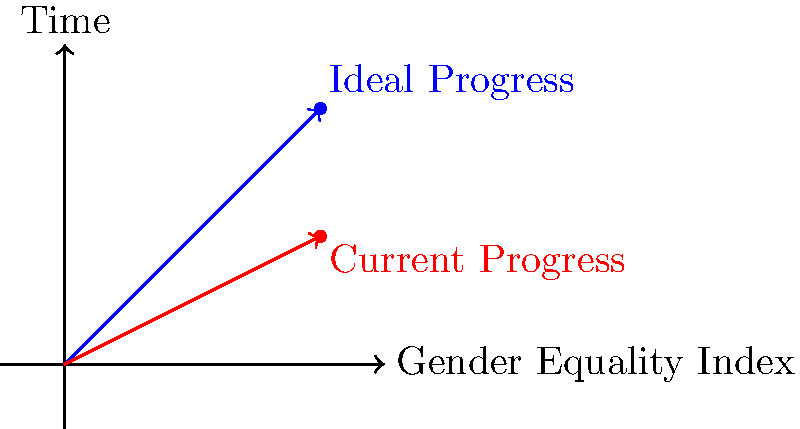In the vector diagram representing gender equality progress over time, the blue arrow shows the ideal progress, while the red arrow shows the current progress. If the magnitude of the ideal progress vector is 4√2 units, what is the magnitude of the current progress vector? To solve this problem, let's follow these steps:

1. Identify the vectors:
   - Blue vector (ideal progress): from (0,0) to (4,4)
   - Red vector (current progress): from (0,0) to (4,2)

2. Calculate the magnitude of the ideal progress vector:
   - Given as 4√2 units

3. Find the components of the current progress vector:
   - x-component: 4 units
   - y-component: 2 units

4. Use the Pythagorean theorem to calculate the magnitude of the current progress vector:
   $$\text{magnitude} = \sqrt{x^2 + y^2}$$
   $$\text{magnitude} = \sqrt{4^2 + 2^2}$$
   $$\text{magnitude} = \sqrt{16 + 4}$$
   $$\text{magnitude} = \sqrt{20}$$
   $$\text{magnitude} = 2\sqrt{5}$$

Therefore, the magnitude of the current progress vector is 2√5 units.
Answer: 2√5 units 